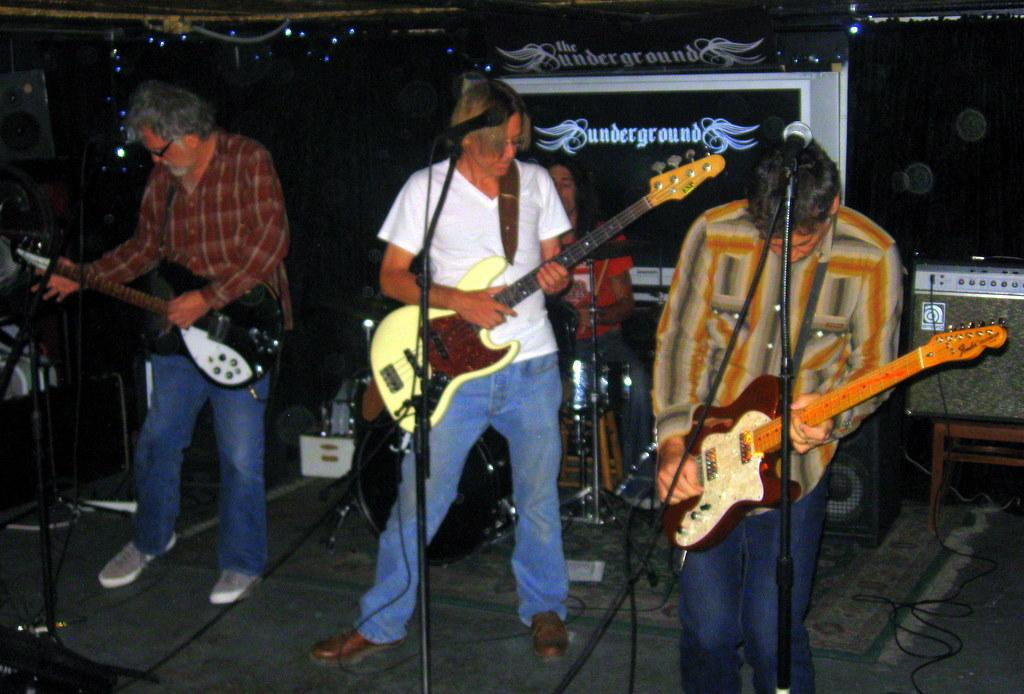How many people are in the image? There are four people in the image. What are the people doing in the image? The people are playing musical instruments. Can you describe anything in the background of the image? Yes, there is a board visible in the background of the image. What type of summer activity is the governor participating in with the people in the image? There is no governor present in the image, and the image does not depict a summer activity. 